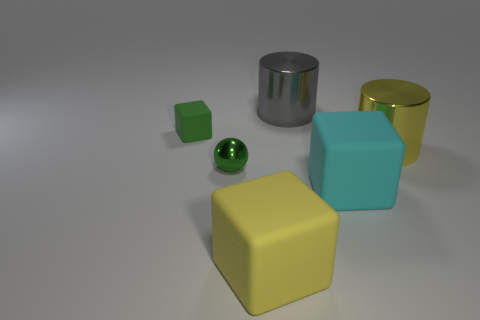Subtract all tiny rubber blocks. How many blocks are left? 2 Add 3 tiny purple matte spheres. How many objects exist? 9 Subtract all cylinders. How many objects are left? 4 Subtract all blue blocks. Subtract all brown spheres. How many blocks are left? 3 Subtract all yellow matte balls. Subtract all big yellow rubber objects. How many objects are left? 5 Add 2 big yellow matte things. How many big yellow matte things are left? 3 Add 1 big blocks. How many big blocks exist? 3 Subtract 1 cyan cubes. How many objects are left? 5 